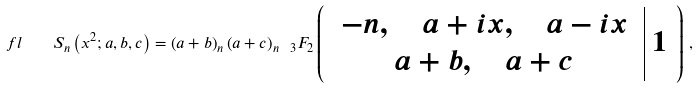<formula> <loc_0><loc_0><loc_500><loc_500>\ f l \quad S _ { n } \left ( x ^ { 2 } ; a , b , c \right ) = \left ( a + b \right ) _ { n } \left ( a + c \right ) _ { n } \ _ { 3 } F _ { 2 } \left ( \begin{array} { c | c } { \begin{array} { c } - n , \quad a + i x , \quad a - i x \\ a + b , \quad a + c \end{array} } & 1 \end{array} \right ) \, ,</formula> 